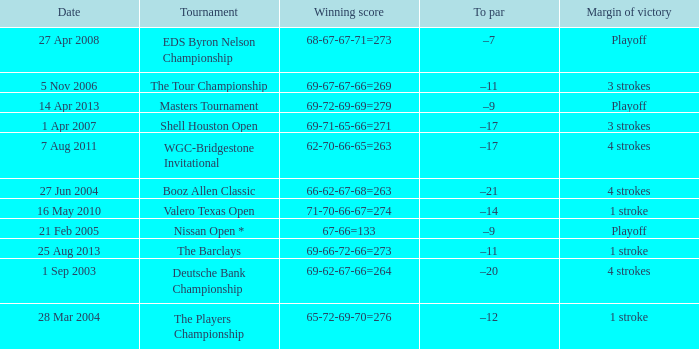Which date has a To par of –12? 28 Mar 2004. 